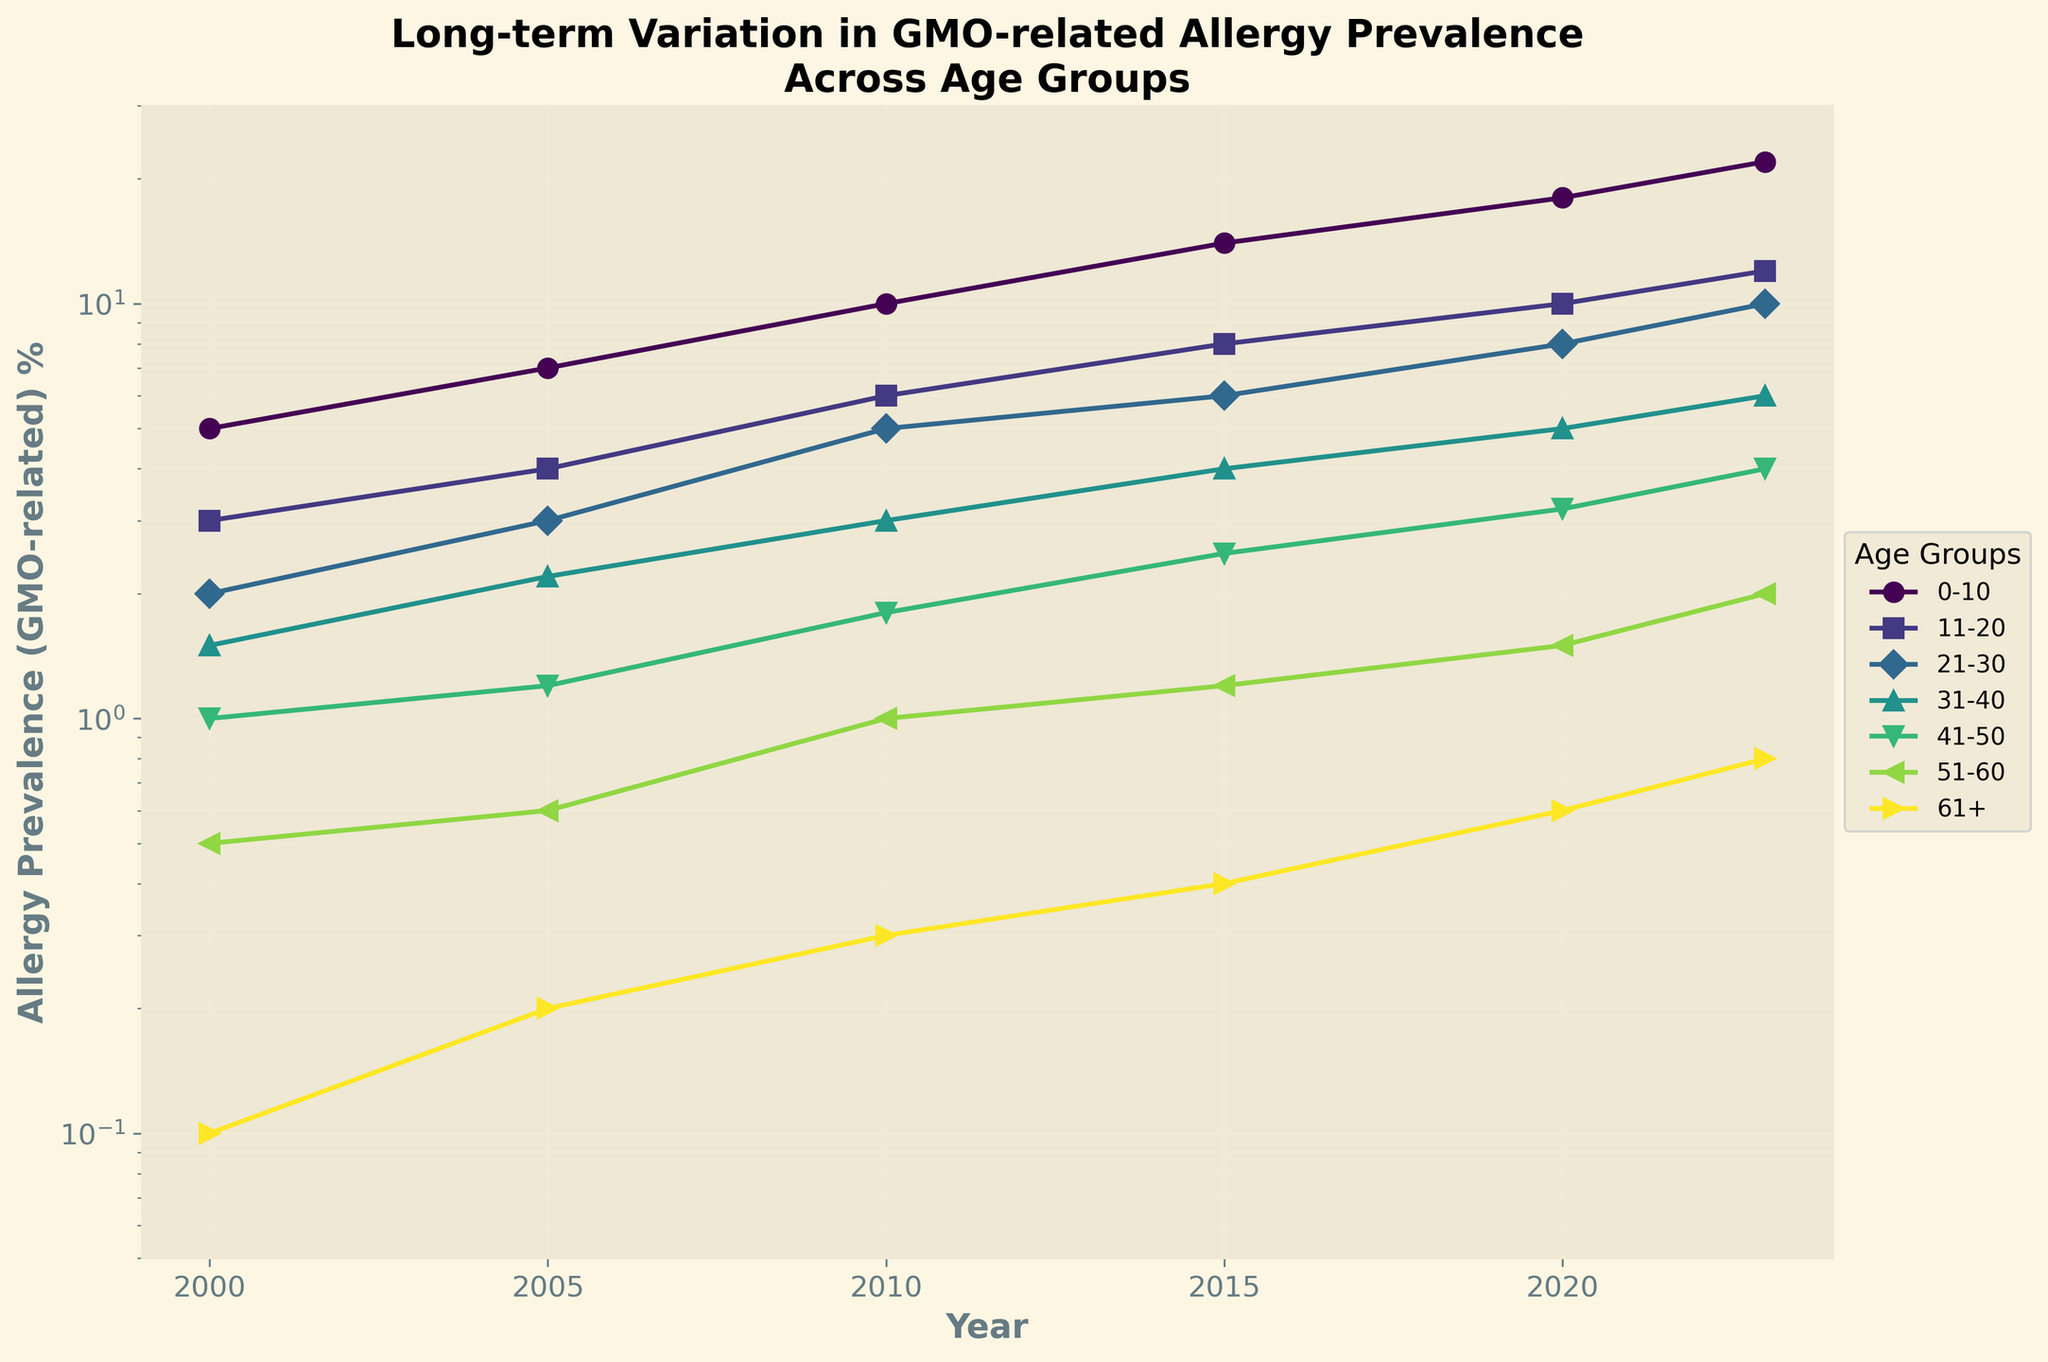What is the title of the figure? The title is located at the top of the plot. It summarizes the main focus of the chart.
Answer: Long-term Variation in GMO-related Allergy Prevalence Across Age Groups Which age group shows the highest prevalence of GMO-related allergies in 2023? To find this, look for the highest data point for the year 2023.
Answer: 0-10 How has the prevalence of GMO-related allergies in the age group 21-30 changed from 2000 to 2023? Inspect the data points for the age group 21-30 from 2000 to 2023 and note the trend.
Answer: Increased By what factor did the prevalence of GMO-related allergies in the age group 61+ change from 2000 to 2023? Divide the 2023 value by the 2000 value to find the multiplicative factor. 0.8 / 0.1 = 8
Answer: 8 Which age group had the smallest increase in prevalence from 2000 to 2023? Compare the changes for each age group by looking at the difference between 2023 and 2000 values.
Answer: 51-60 What is the shape of the curve for the 11-20 age group? Analyze the trend and pattern for the line corresponding to the 11-20 age group.
Answer: Upward trend Between which years did the age group 0-10 see the largest increase in allergy prevalence? Identify the segment with the steepest incline for the 0-10 age group.
Answer: 2010 to 2015 Does any age group show a decrease in prevalence at any point? Examine each age group's line to determine if any declines or dips occur.
Answer: No Which age group has the lowest prevalence of GMO-related allergies in 2005? Look at the 2005 data points and identify the lowest value.
Answer: 61+ How does the prevalence of GMO-related allergies change with age in 2020? Compare the data points for each age group in the year 2020.
Answer: Decreases with age 